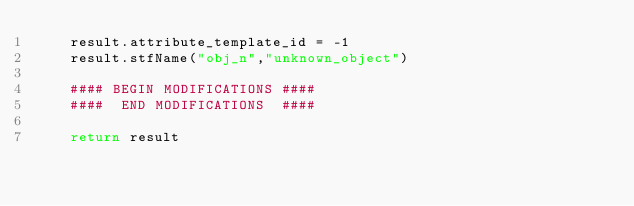<code> <loc_0><loc_0><loc_500><loc_500><_Python_>	result.attribute_template_id = -1
	result.stfName("obj_n","unknown_object")		
	
	#### BEGIN MODIFICATIONS ####
	####  END MODIFICATIONS  ####
	
	return result</code> 